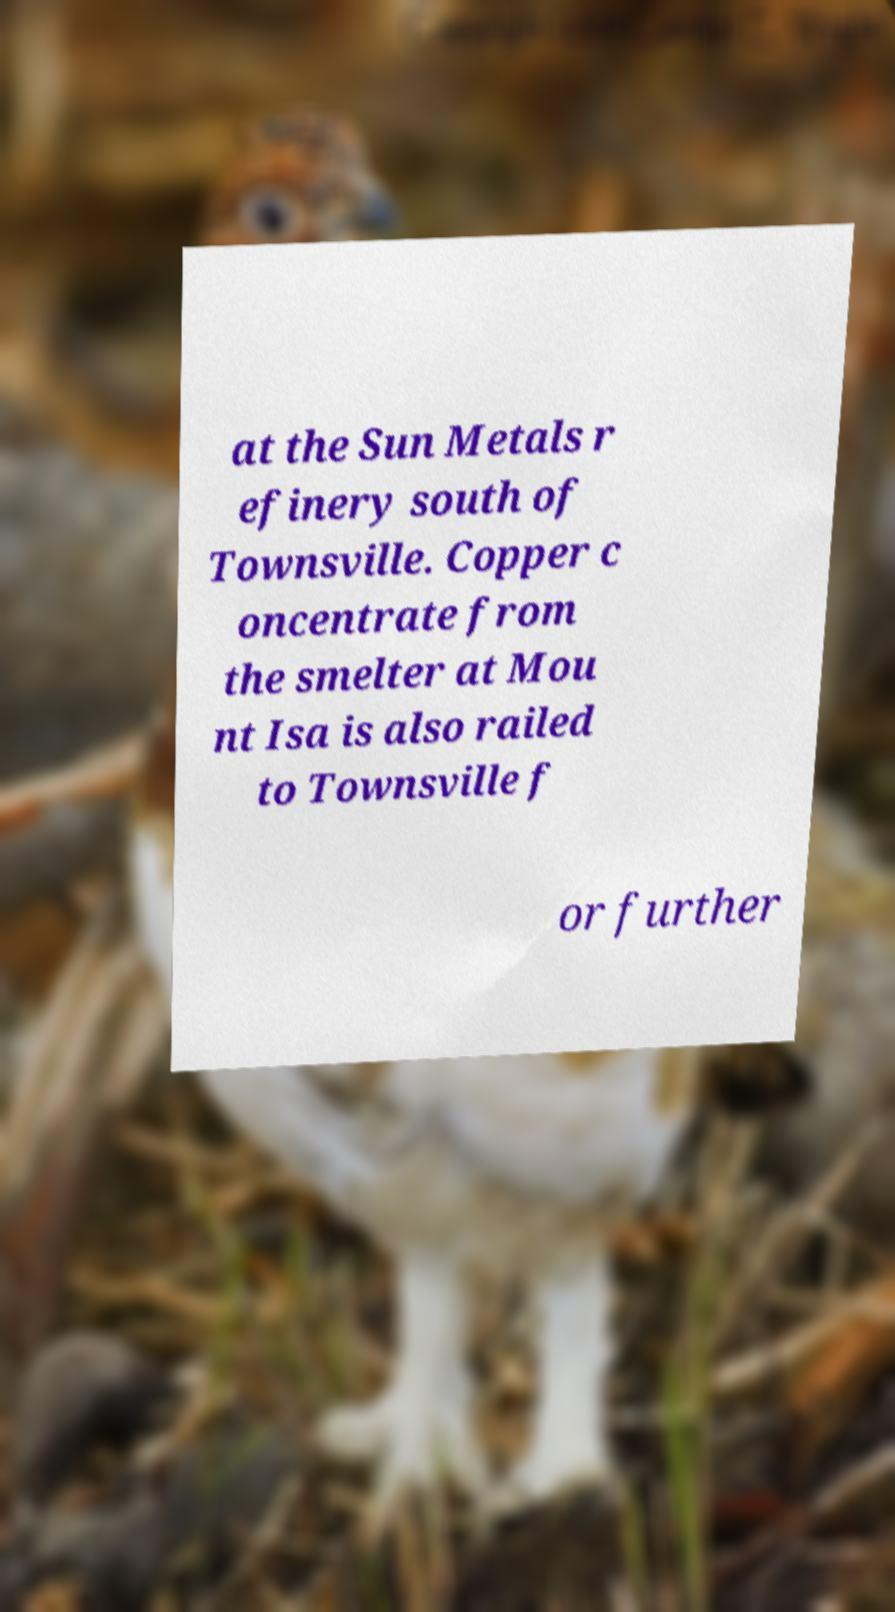Could you assist in decoding the text presented in this image and type it out clearly? at the Sun Metals r efinery south of Townsville. Copper c oncentrate from the smelter at Mou nt Isa is also railed to Townsville f or further 